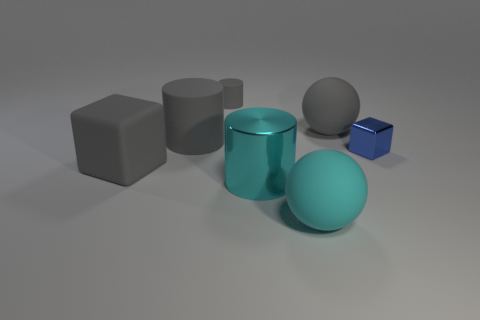The small metallic block has what color?
Keep it short and to the point. Blue. There is a small object that is on the right side of the big cyan matte sphere; what is it made of?
Make the answer very short. Metal. Is the number of cyan metallic objects behind the big gray ball the same as the number of large blue blocks?
Offer a very short reply. Yes. Does the small gray matte thing have the same shape as the big cyan metal object?
Your answer should be compact. Yes. Is there any other thing that has the same color as the tiny rubber object?
Make the answer very short. Yes. There is a thing that is both to the right of the large gray cylinder and to the left of the cyan shiny object; what is its shape?
Keep it short and to the point. Cylinder. Is the number of gray matte blocks behind the gray rubber block the same as the number of tiny blue cubes that are in front of the small blue metallic block?
Provide a succinct answer. Yes. What number of balls are either large cyan shiny objects or small purple things?
Keep it short and to the point. 0. How many large things have the same material as the small block?
Offer a terse response. 1. What is the shape of the thing that is the same color as the metallic cylinder?
Provide a short and direct response. Sphere. 